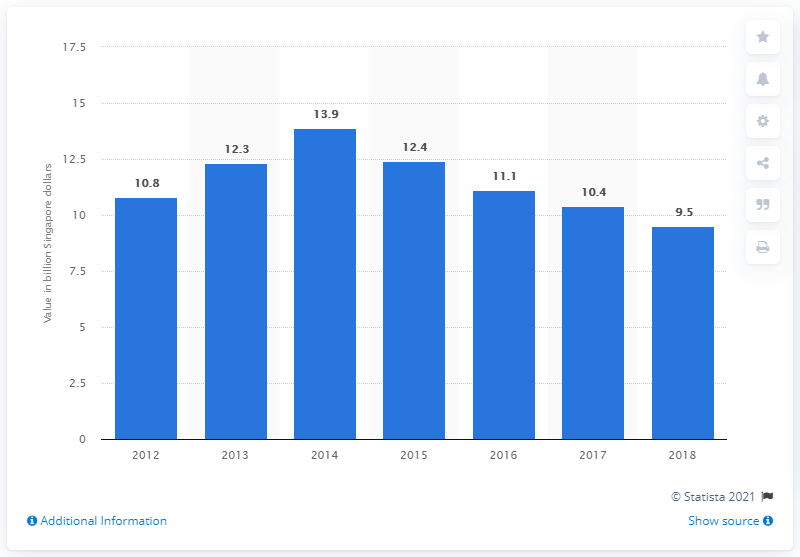Identify some key points in this picture. In 2018, the revenue of the Singaporean telecom market was approximately 9.5 billion US dollars. 